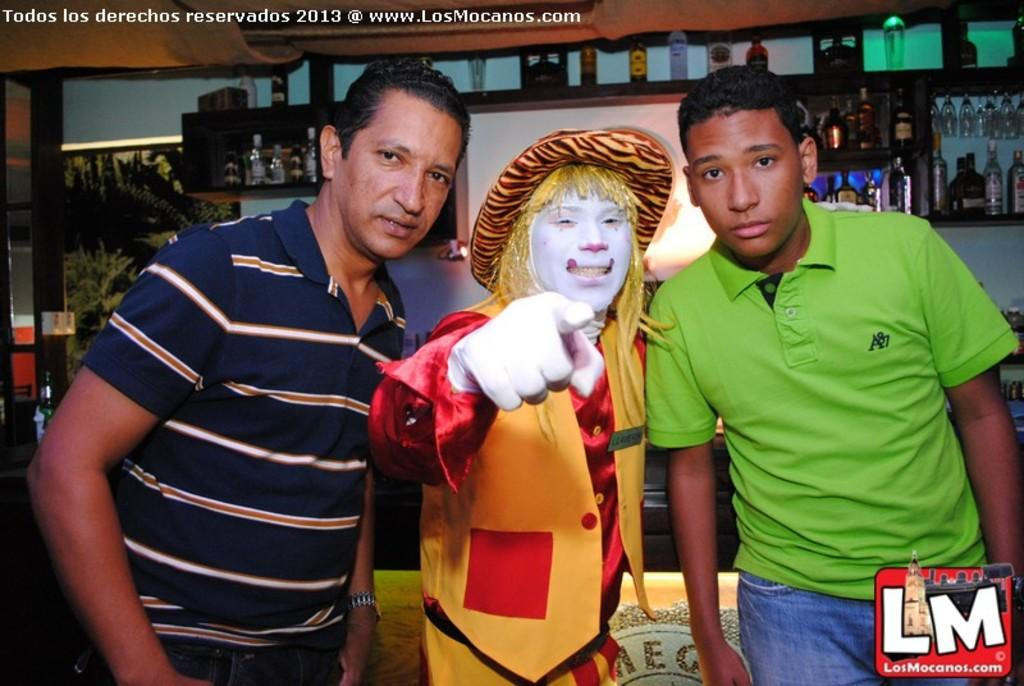What are the main subjects in the center of the image? There are persons standing in the center of the image. What can be seen in the background of the image? There are bottles, a whiteboard, and trees in the background of the image. What is the condition of the whiteboard in the image? The whiteboard is empty in the image. What type of field is visible in the image? There is no field visible in the image; it features persons standing in the center and various objects in the background. 